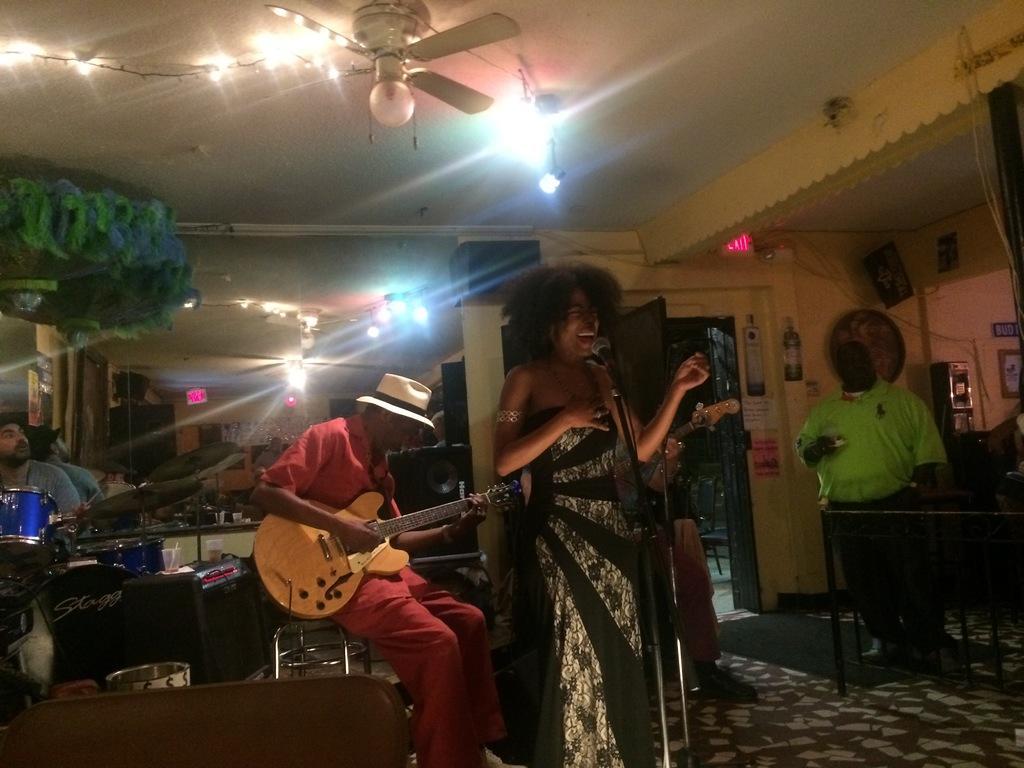Can you describe this image briefly? In this image a woman stand wearing a black color jacket her mouth is open and right side i can see a person ,wearing a green color t-shirt,on the left side i can see a person holding a guitar wearing red color t -shirt and there are some lights visible on the right side and there is a fan on the roof and there are some musical instrument kept on the left side. 